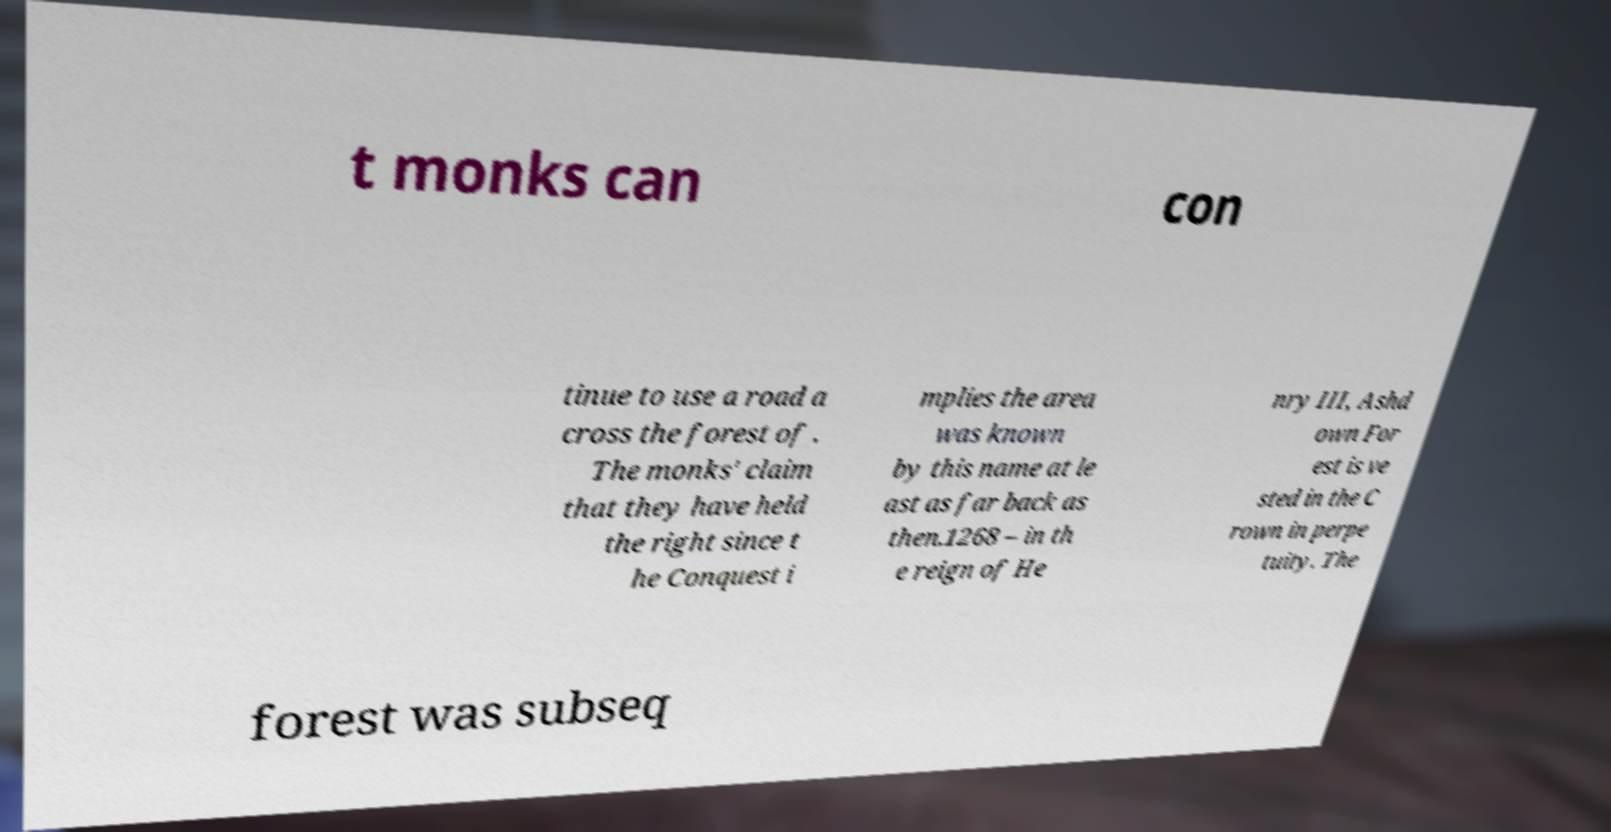Could you assist in decoding the text presented in this image and type it out clearly? t monks can con tinue to use a road a cross the forest of . The monks' claim that they have held the right since t he Conquest i mplies the area was known by this name at le ast as far back as then.1268 – in th e reign of He nry III, Ashd own For est is ve sted in the C rown in perpe tuity. The forest was subseq 